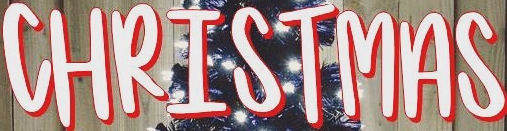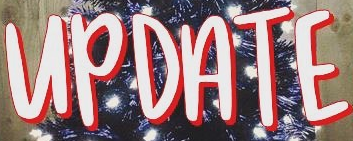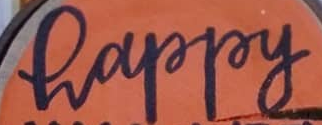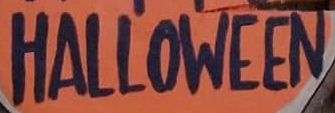Identify the words shown in these images in order, separated by a semicolon. CHRISTMAS; UPDATE; happy; HALLOWEEN 